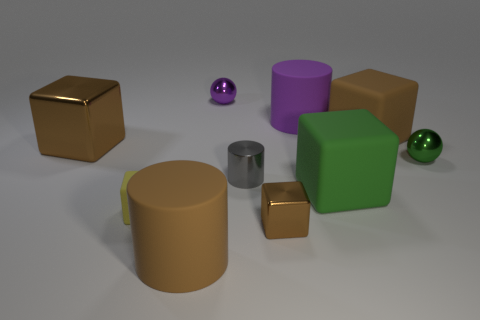What shape is the green thing that is made of the same material as the gray cylinder?
Provide a succinct answer. Sphere. Are there more big purple rubber things than tiny gray cubes?
Give a very brief answer. Yes. There is a tiny gray metallic thing; does it have the same shape as the brown thing that is to the left of the big brown cylinder?
Offer a very short reply. No. What material is the tiny gray thing?
Your answer should be very brief. Metal. The metal block that is behind the matte block on the left side of the large brown rubber thing on the left side of the purple sphere is what color?
Give a very brief answer. Brown. What material is the large brown thing that is the same shape as the small gray thing?
Offer a very short reply. Rubber. What number of gray objects have the same size as the gray cylinder?
Your answer should be compact. 0. How many big matte blocks are there?
Keep it short and to the point. 2. Is the yellow object made of the same material as the big brown object in front of the big brown shiny block?
Provide a short and direct response. Yes. How many brown objects are either small shiny cylinders or shiny balls?
Ensure brevity in your answer.  0. 